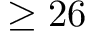<formula> <loc_0><loc_0><loc_500><loc_500>\geq 2 6</formula> 